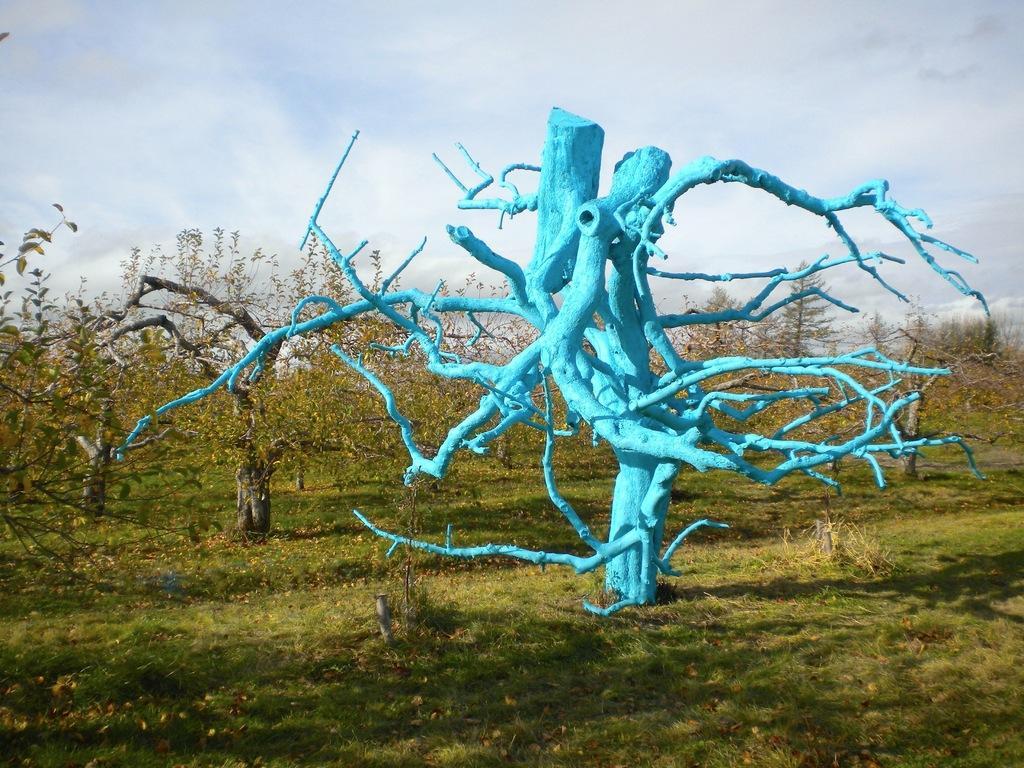In one or two sentences, can you explain what this image depicts? In this image we can see many trees. We can see a painted tree. There is a grassy land in the image. We can see the cloudy sky in the image. 